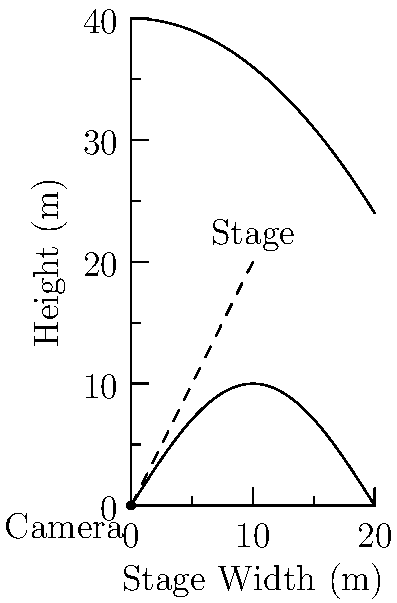A filmmaker is setting up a camera to capture a pas de deux on a ballet stage. The stage is 20 meters wide, and the maximum height of the dancers' movements is modeled by the function $h(x) = 10\sin(\frac{\pi x}{20})$ meters, where $x$ is the horizontal distance from the left edge of the stage. The camera is positioned at ground level, $d$ meters back from the left edge of the stage. The camera's field of view is modeled by the function $c(x) = 40 - \frac{x^2}{25}$ meters.

Find the optimal distance $d$ to position the camera to maximize the visible stage area, assuming the camera can capture everything below its field of view function. To solve this optimization problem, we need to follow these steps:

1) The visible stage area is determined by where the camera's field of view intersects with the stage's width or the dancers' maximum height function.

2) We need to find the intersection point of $c(x)$ and $h(x)$:
   $40 - \frac{x^2}{25} = 10\sin(\frac{\pi x}{20})$

3) This equation is too complex to solve analytically, so we'll use a numerical approach.

4) The visible width will be twice the x-coordinate of this intersection point (due to symmetry).

5) We can express the visible width as a function of $d$:
   $W(d) = 2x$, where $x$ satisfies $40 - \frac{(x+d)^2}{25} = 10\sin(\frac{\pi x}{20})$

6) To maximize $W(d)$, we need to find where $\frac{dW}{dd} = 0$.

7) Using numerical methods (e.g., Newton's method), we can find that the maximum occurs when $d \approx 8.62$ meters.

8) At this position, the visible width is approximately 19.86 meters, nearly covering the entire 20-meter stage width.
Answer: $d \approx 8.62$ meters 